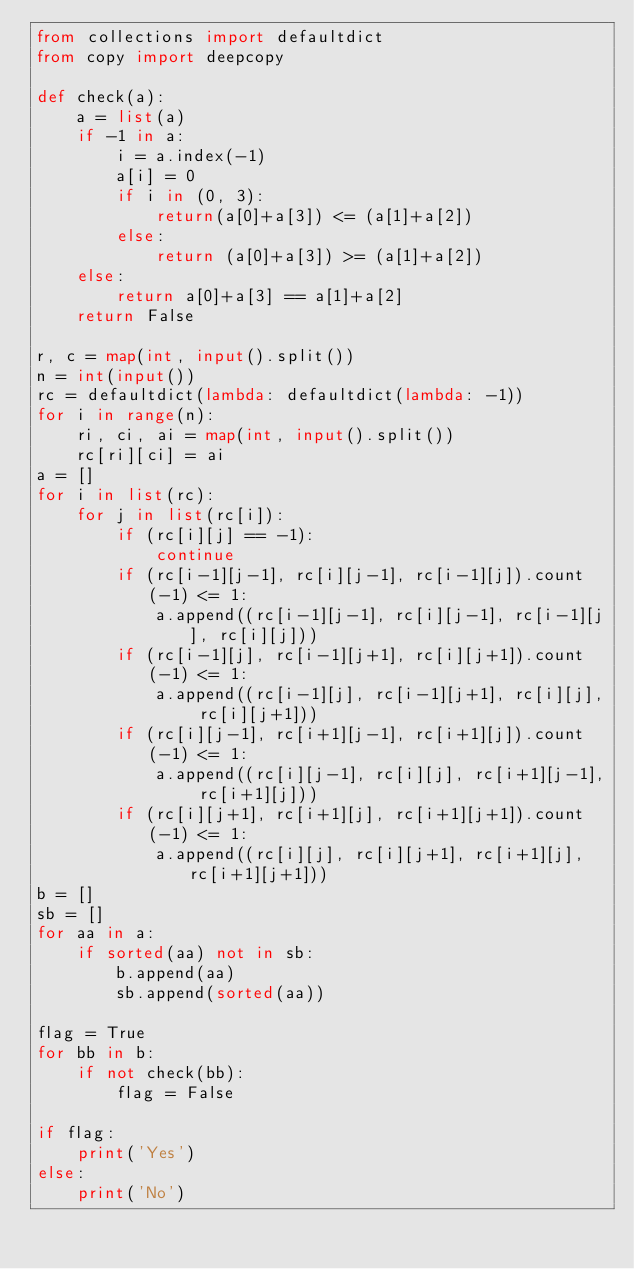Convert code to text. <code><loc_0><loc_0><loc_500><loc_500><_Python_>from collections import defaultdict
from copy import deepcopy

def check(a):
    a = list(a)
    if -1 in a:
        i = a.index(-1)
        a[i] = 0
        if i in (0, 3):
            return(a[0]+a[3]) <= (a[1]+a[2])
        else:
            return (a[0]+a[3]) >= (a[1]+a[2])
    else:
        return a[0]+a[3] == a[1]+a[2]
    return False

r, c = map(int, input().split())
n = int(input())
rc = defaultdict(lambda: defaultdict(lambda: -1))
for i in range(n):
    ri, ci, ai = map(int, input().split())
    rc[ri][ci] = ai
a = []
for i in list(rc):
    for j in list(rc[i]):
        if (rc[i][j] == -1):
            continue
        if (rc[i-1][j-1], rc[i][j-1], rc[i-1][j]).count(-1) <= 1:
            a.append((rc[i-1][j-1], rc[i][j-1], rc[i-1][j], rc[i][j]))
        if (rc[i-1][j], rc[i-1][j+1], rc[i][j+1]).count(-1) <= 1:
            a.append((rc[i-1][j], rc[i-1][j+1], rc[i][j], rc[i][j+1]))
        if (rc[i][j-1], rc[i+1][j-1], rc[i+1][j]).count(-1) <= 1:
            a.append((rc[i][j-1], rc[i][j], rc[i+1][j-1], rc[i+1][j]))
        if (rc[i][j+1], rc[i+1][j], rc[i+1][j+1]).count(-1) <= 1:
            a.append((rc[i][j], rc[i][j+1], rc[i+1][j], rc[i+1][j+1]))
b = []
sb = []
for aa in a:
    if sorted(aa) not in sb:
        b.append(aa)
        sb.append(sorted(aa))

flag = True
for bb in b:
    if not check(bb):
        flag = False

if flag:
    print('Yes')
else:
    print('No')
</code> 